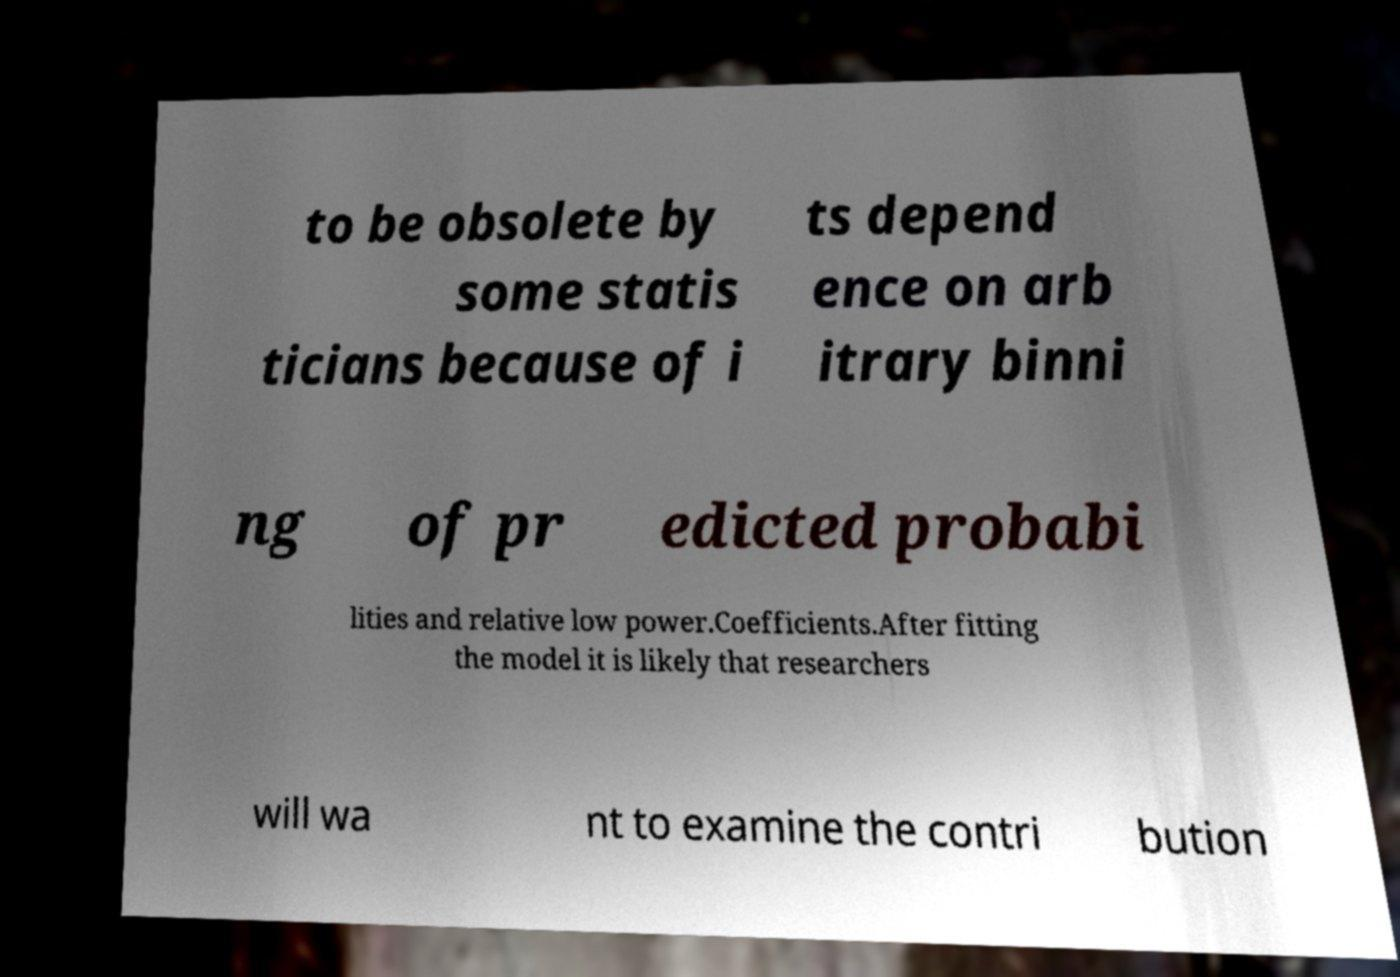Please read and relay the text visible in this image. What does it say? to be obsolete by some statis ticians because of i ts depend ence on arb itrary binni ng of pr edicted probabi lities and relative low power.Coefficients.After fitting the model it is likely that researchers will wa nt to examine the contri bution 